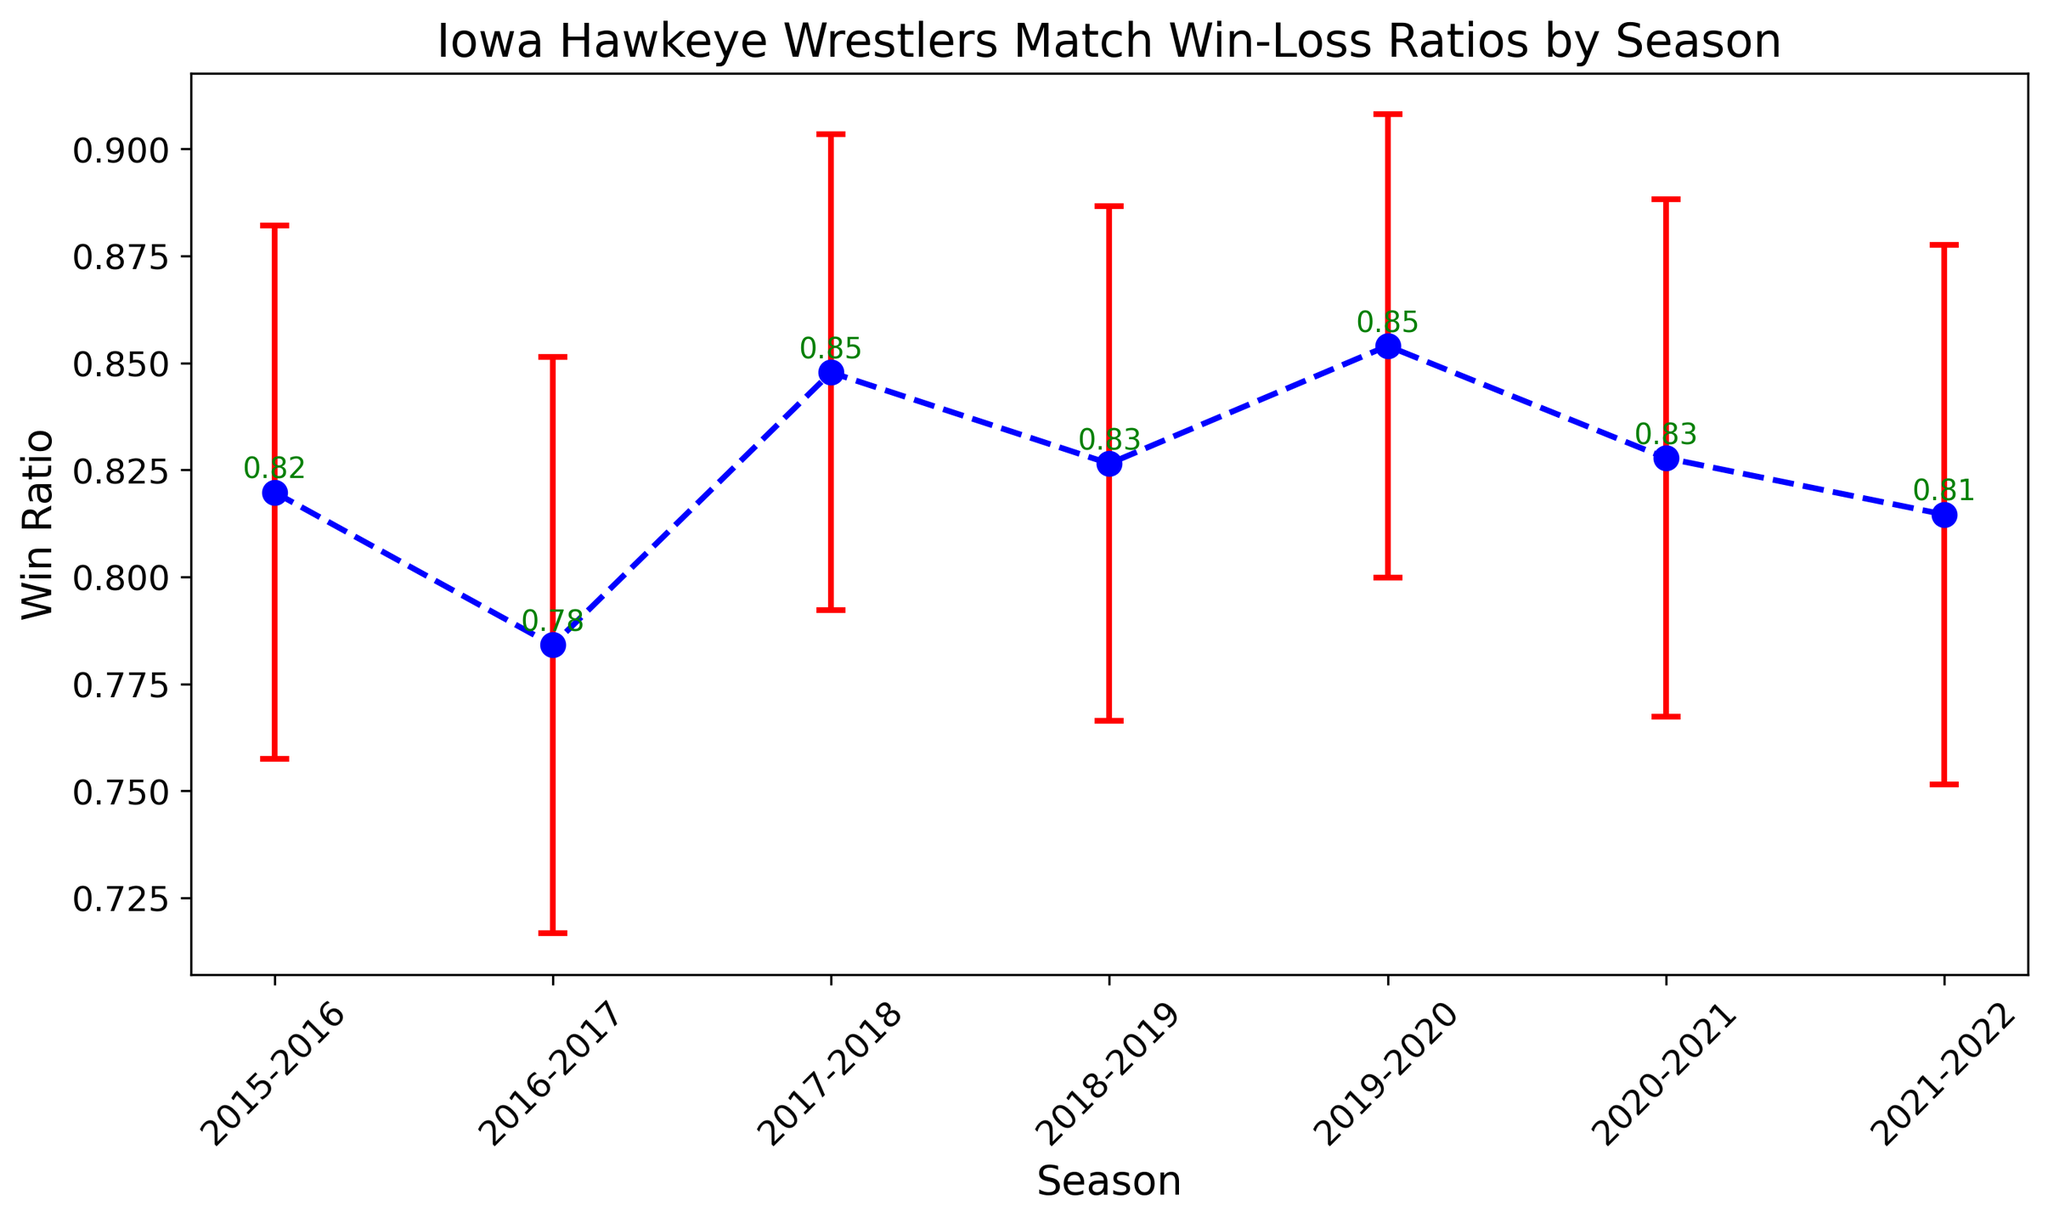What is the win ratio in the 2017-2018 season? Refer to the figure where the win ratio annotated for the 2017-2018 season is shown as 0.85.
Answer: 0.85 What season had the highest win ratio? Check the win ratios listed for each season in the figure. The highest win ratio is in the 2019-2020 season, annotated as 0.854.
Answer: 2019-2020 What season had the lowest win ratio? Look at the win ratios for each season. The lowest win ratio is in the 2016-2017 season, annotated as 0.784.
Answer: 2016-2017 Compare the win ratios between the 2015-2016 and 2018-2019 seasons. Which one is higher? Find the win ratios for both seasons. The 2015-2016 season has a win ratio of 0.8198 and the 2018-2019 season has a win ratio of 0.8265. The 2018-2019 season has a higher win ratio.
Answer: 2018-2019 What is the average win ratio over the seven seasons displayed? Sum the win ratios for all seven seasons: (0.8198 + 0.7841 + 0.8478 + 0.8265 + 0.8540 + 0.8278 + 0.8146) = 5.7746. Divide by the number of seasons: 5.7746 / 7 ≈ 0.824.
Answer: 0.824 How does the win ratio for the 2020-2021 season compare to the average win ratio for all seasons? Calculate the average win ratio for all seasons (as previously computed: 0.824). The win ratio for the 2020-2021 season is 0.8278. Since 0.8278 is slightly above the average of 0.824, the 2020-2021 season's win ratio is higher than the average.
Answer: Higher Which season has the largest win ratio error? Refer to the figure for the win ratio error bars. The 2016-2017 season has the largest error bar with a value of 0.0674.
Answer: 2016-2017 What's the difference in win ratio between the 2019-2020 and 2021-2022 seasons? Subtract the 2021-2022 win ratio (0.8146) from the 2019-2020 win ratio (0.8540): 0.8540 - 0.8146 = 0.0394.
Answer: 0.0394 What is the trend of win ratios over the seasons? Increasing, decreasing, or stable? Observe the win ratios from 2015-2016 to 2021-2022. The trend is generally stable with some fluctuations but no consistent increasing or decreasing pattern.
Answer: Stable 